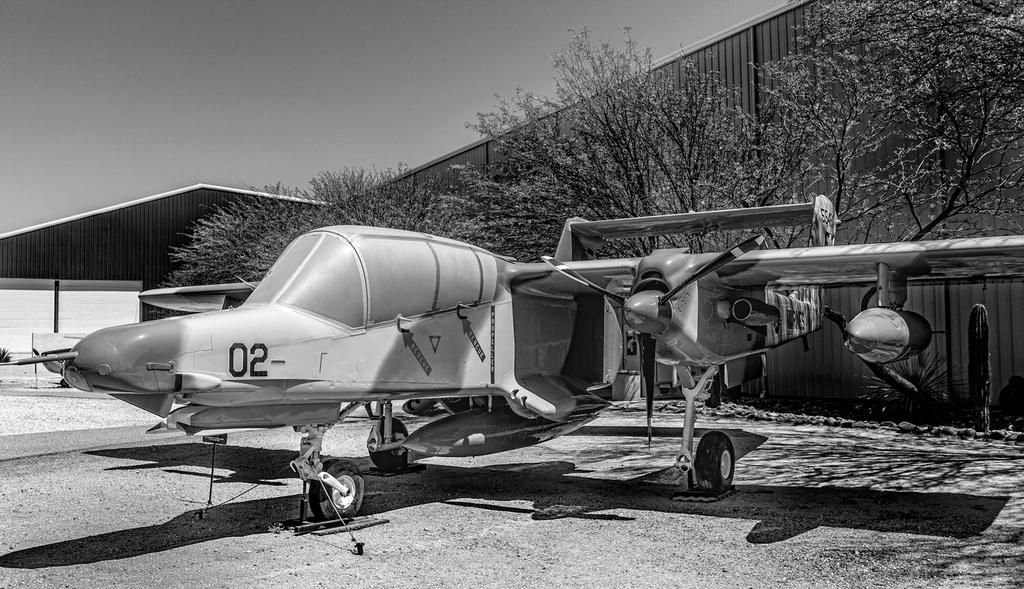<image>
Write a terse but informative summary of the picture. a black and white plane with 02- on the cockpit 